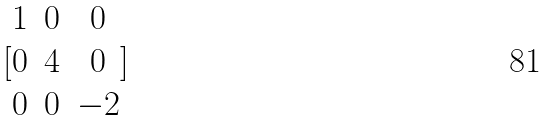<formula> <loc_0><loc_0><loc_500><loc_500>[ \begin{matrix} 1 & 0 & 0 \\ 0 & 4 & 0 \\ 0 & 0 & - 2 \end{matrix} ]</formula> 